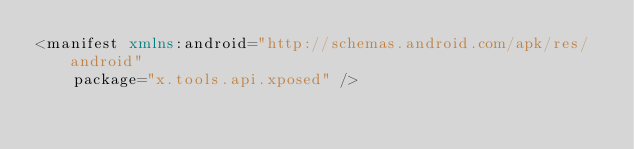Convert code to text. <code><loc_0><loc_0><loc_500><loc_500><_XML_><manifest xmlns:android="http://schemas.android.com/apk/res/android"
    package="x.tools.api.xposed" />
</code> 